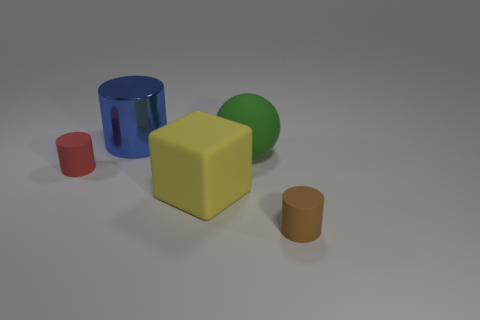What is the texture of the objects on the surface? The objects on the surface have varied textures. The blue and brown cylinders seem to have a smooth, metallic sheen, indicative of a metal-like material. The red cylinder and the yellow block appear to have a matte finish, which suggests a rubbery or plastic material. 